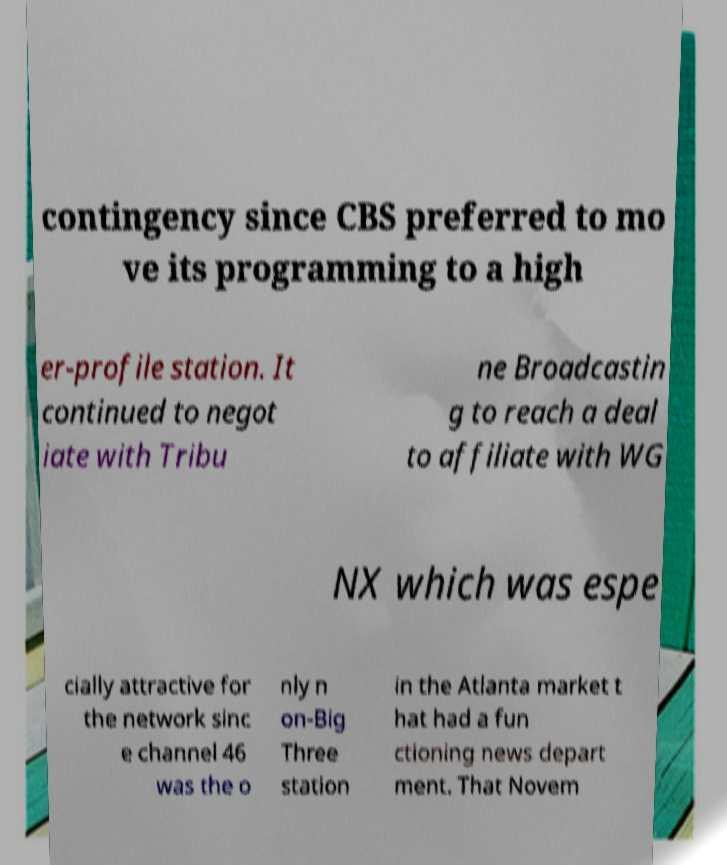Can you read and provide the text displayed in the image?This photo seems to have some interesting text. Can you extract and type it out for me? contingency since CBS preferred to mo ve its programming to a high er-profile station. It continued to negot iate with Tribu ne Broadcastin g to reach a deal to affiliate with WG NX which was espe cially attractive for the network sinc e channel 46 was the o nly n on-Big Three station in the Atlanta market t hat had a fun ctioning news depart ment. That Novem 